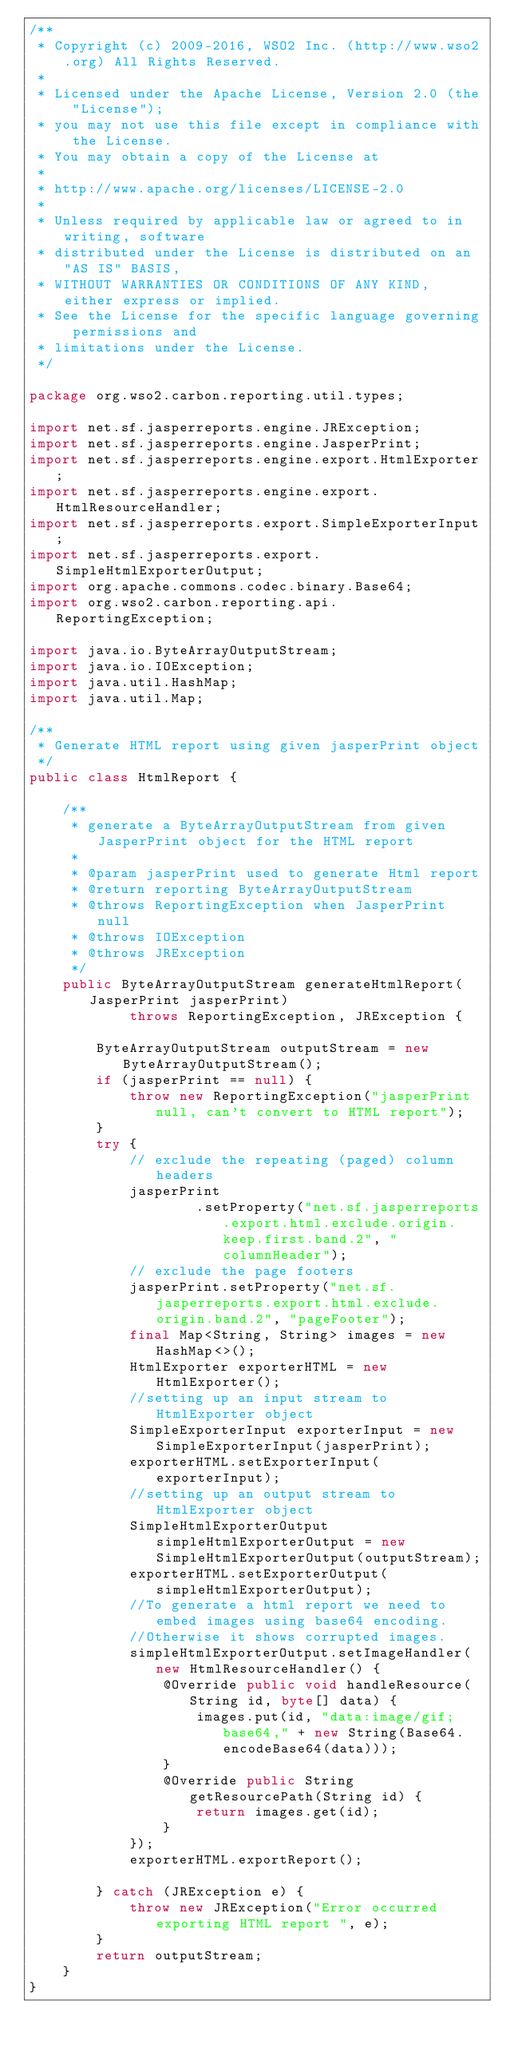Convert code to text. <code><loc_0><loc_0><loc_500><loc_500><_Java_>/**
 * Copyright (c) 2009-2016, WSO2 Inc. (http://www.wso2.org) All Rights Reserved.
 *
 * Licensed under the Apache License, Version 2.0 (the "License");
 * you may not use this file except in compliance with the License.
 * You may obtain a copy of the License at
 *
 * http://www.apache.org/licenses/LICENSE-2.0
 *
 * Unless required by applicable law or agreed to in writing, software
 * distributed under the License is distributed on an "AS IS" BASIS,
 * WITHOUT WARRANTIES OR CONDITIONS OF ANY KIND, either express or implied.
 * See the License for the specific language governing permissions and
 * limitations under the License.
 */

package org.wso2.carbon.reporting.util.types;

import net.sf.jasperreports.engine.JRException;
import net.sf.jasperreports.engine.JasperPrint;
import net.sf.jasperreports.engine.export.HtmlExporter;
import net.sf.jasperreports.engine.export.HtmlResourceHandler;
import net.sf.jasperreports.export.SimpleExporterInput;
import net.sf.jasperreports.export.SimpleHtmlExporterOutput;
import org.apache.commons.codec.binary.Base64;
import org.wso2.carbon.reporting.api.ReportingException;

import java.io.ByteArrayOutputStream;
import java.io.IOException;
import java.util.HashMap;
import java.util.Map;

/**
 * Generate HTML report using given jasperPrint object
 */
public class HtmlReport {

    /**
     * generate a ByteArrayOutputStream from given JasperPrint object for the HTML report
     *
     * @param jasperPrint used to generate Html report
     * @return reporting ByteArrayOutputStream
     * @throws ReportingException when JasperPrint null
     * @throws IOException
     * @throws JRException
     */
    public ByteArrayOutputStream generateHtmlReport(JasperPrint jasperPrint)
            throws ReportingException, JRException {

        ByteArrayOutputStream outputStream = new ByteArrayOutputStream();
        if (jasperPrint == null) {
            throw new ReportingException("jasperPrint null, can't convert to HTML report");
        }
        try {
            // exclude the repeating (paged) column headers
            jasperPrint
                    .setProperty("net.sf.jasperreports.export.html.exclude.origin.keep.first.band.2", "columnHeader");
            // exclude the page footers
            jasperPrint.setProperty("net.sf.jasperreports.export.html.exclude.origin.band.2", "pageFooter");
            final Map<String, String> images = new HashMap<>();
            HtmlExporter exporterHTML = new HtmlExporter();
            //setting up an input stream to HtmlExporter object
            SimpleExporterInput exporterInput = new SimpleExporterInput(jasperPrint);
            exporterHTML.setExporterInput(exporterInput);
            //setting up an output stream to HtmlExporter object
            SimpleHtmlExporterOutput simpleHtmlExporterOutput = new SimpleHtmlExporterOutput(outputStream);
            exporterHTML.setExporterOutput(simpleHtmlExporterOutput);
            //To generate a html report we need to embed images using base64 encoding.
            //Otherwise it shows corrupted images.
            simpleHtmlExporterOutput.setImageHandler(new HtmlResourceHandler() {
                @Override public void handleResource(String id, byte[] data) {
                    images.put(id, "data:image/gif;base64," + new String(Base64.encodeBase64(data)));
                }
                @Override public String getResourcePath(String id) {
                    return images.get(id);
                }
            });
            exporterHTML.exportReport();

        } catch (JRException e) {
            throw new JRException("Error occurred exporting HTML report ", e);
        }
        return outputStream;
    }
}
</code> 